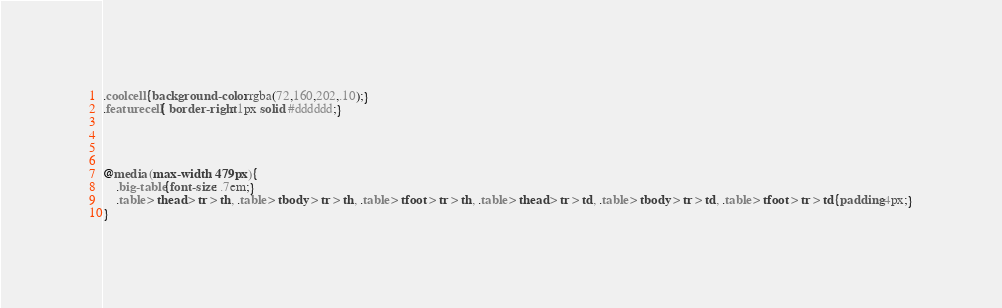Convert code to text. <code><loc_0><loc_0><loc_500><loc_500><_CSS_>.coolcell{background-color: rgba(72,160,202,.10);}
.featurecell{ border-right: 1px solid #dddddd;}




@media (max-width: 479px){
    .big-table{font-size: .7em;}
    .table > thead > tr > th, .table > tbody > tr > th, .table > tfoot > tr > th, .table > thead > tr > td, .table > tbody > tr > td, .table > tfoot > tr > td{padding:4px;}
}</code> 